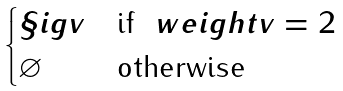Convert formula to latex. <formula><loc_0><loc_0><loc_500><loc_500>\begin{cases} \S i g { v } & \text {if } \ w e i g h t { v } = 2 \\ \varnothing & \text {otherwise} \end{cases}</formula> 